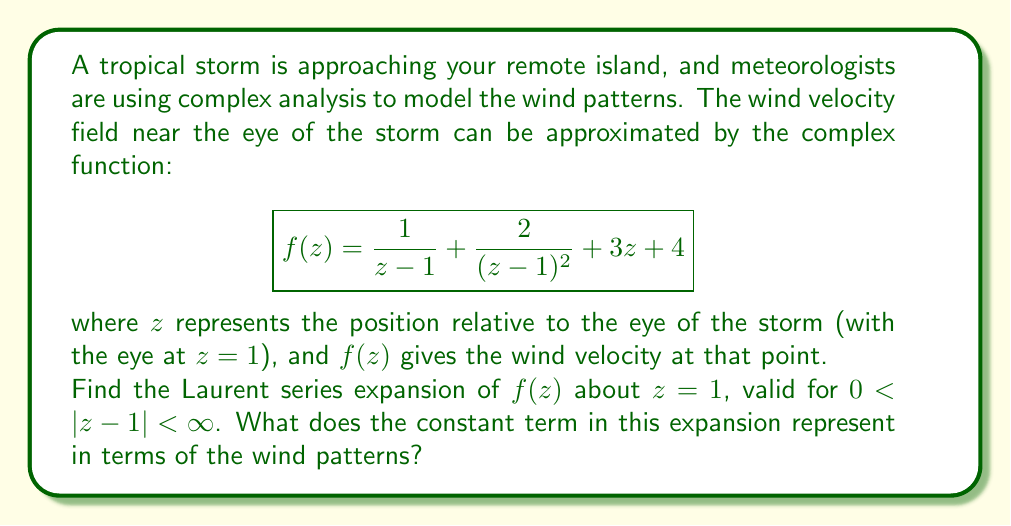Give your solution to this math problem. To find the Laurent series expansion of $f(z)$ about $z=1$, we need to express each term in the function as a power series in $(z-1)$.

1) For the term $\frac{1}{z-1}$:
   This is already in the form of a Laurent series term with $n=-1$.

2) For the term $\frac{2}{(z-1)^2}$:
   This is also already in Laurent series form with $n=-2$.

3) For the term $3z$:
   We can rewrite this as $3(z-1+1) = 3(z-1) + 3$

4) For the constant term 4:
   This remains as is.

Combining all these terms:

$$f(z) = \frac{1}{z-1} + \frac{2}{(z-1)^2} + 3(z-1) + 7$$

This is the Laurent series expansion of $f(z)$ about $z=1$. We can write it in standard form as:

$$f(z) = \frac{2}{(z-1)^2} + \frac{1}{z-1} + 7 + 3(z-1)$$

The constant term in this expansion is 7.

In terms of wind patterns, the constant term represents the background wind velocity that is present regardless of the distance from the eye of the storm. This could be interpreted as the overall movement of the storm system or the prevailing winds in the region.
Answer: The Laurent series expansion of $f(z)$ about $z=1$ is:

$$f(z) = \frac{2}{(z-1)^2} + \frac{1}{z-1} + 7 + 3(z-1)$$

The constant term is 7, representing the background wind velocity independent of the distance from the storm's eye. 